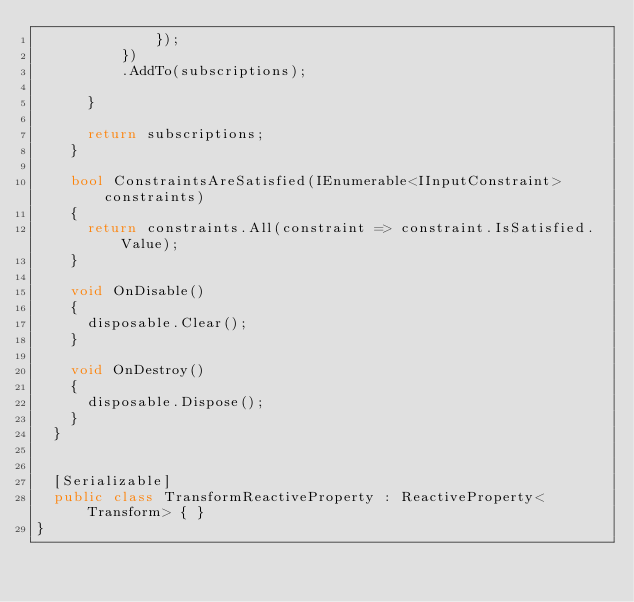Convert code to text. <code><loc_0><loc_0><loc_500><loc_500><_C#_>              });
          })
          .AddTo(subscriptions);

      }

      return subscriptions;
    }

    bool ConstraintsAreSatisfied(IEnumerable<IInputConstraint> constraints)
    {
      return constraints.All(constraint => constraint.IsSatisfied.Value);
    }

    void OnDisable()
    {
      disposable.Clear();
    }

    void OnDestroy()
    {
      disposable.Dispose();
    }
  }


  [Serializable]
  public class TransformReactiveProperty : ReactiveProperty<Transform> { }
}</code> 